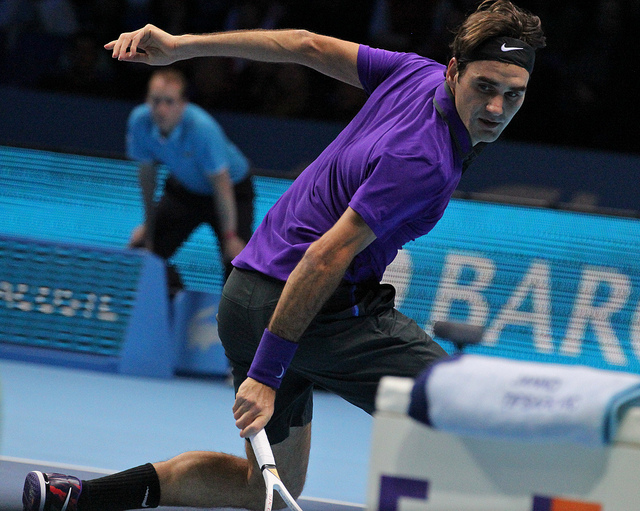<image>Whose picture is this? I don't know whose picture it is. It can be of a tennis player like Roger Federer, or it could belong to the photographer. Whose picture is this? I don't know whose picture this is. It could be the photographer's or someone else's. 